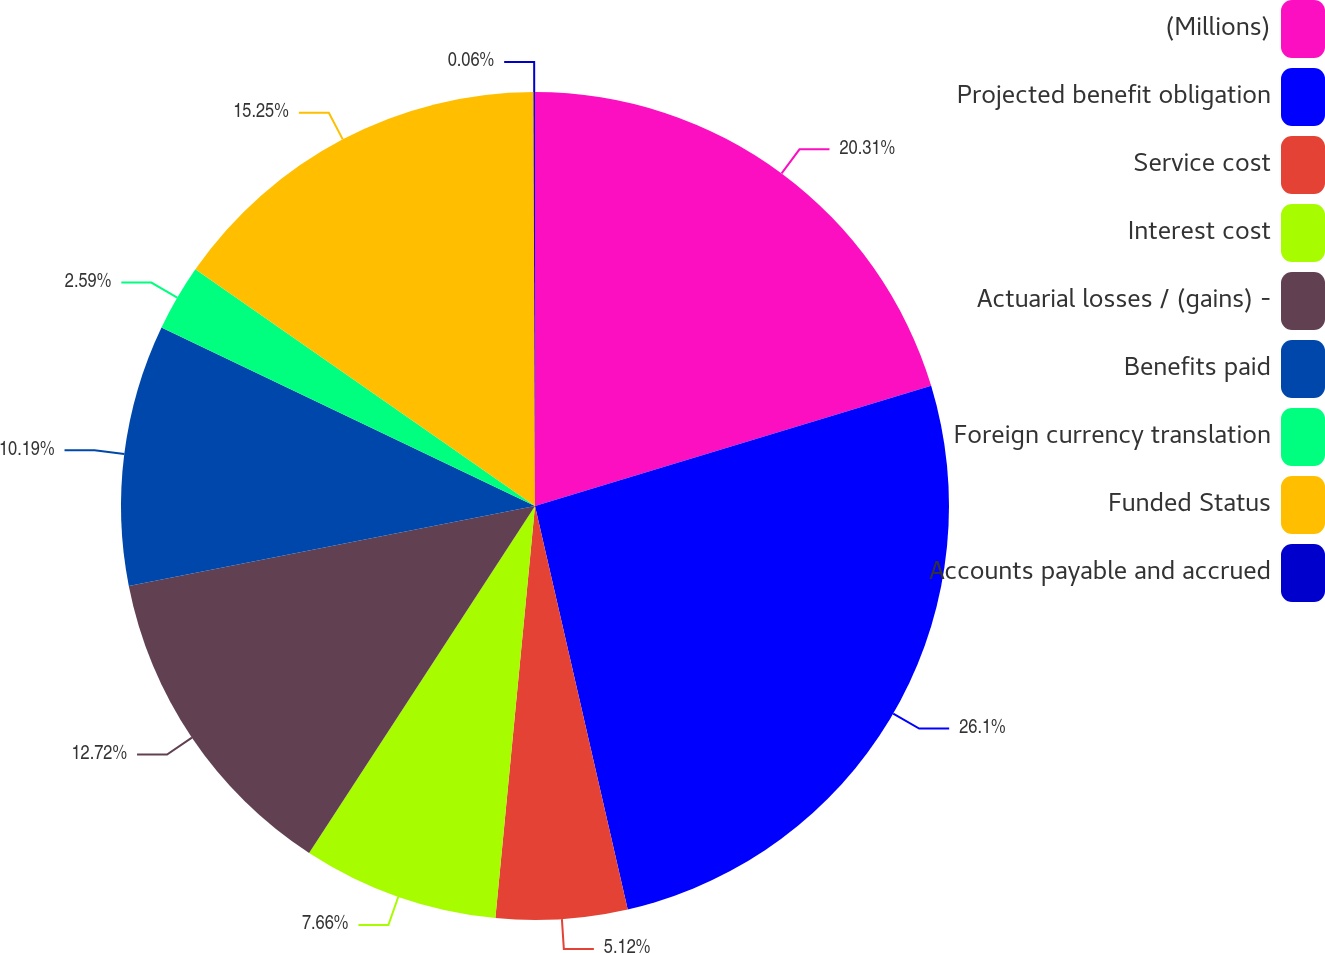<chart> <loc_0><loc_0><loc_500><loc_500><pie_chart><fcel>(Millions)<fcel>Projected benefit obligation<fcel>Service cost<fcel>Interest cost<fcel>Actuarial losses / (gains) -<fcel>Benefits paid<fcel>Foreign currency translation<fcel>Funded Status<fcel>Accounts payable and accrued<nl><fcel>20.31%<fcel>26.09%<fcel>5.12%<fcel>7.66%<fcel>12.72%<fcel>10.19%<fcel>2.59%<fcel>15.25%<fcel>0.06%<nl></chart> 